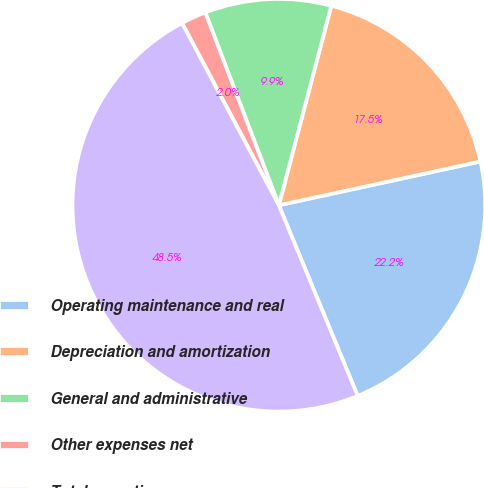Convert chart. <chart><loc_0><loc_0><loc_500><loc_500><pie_chart><fcel>Operating maintenance and real<fcel>Depreciation and amortization<fcel>General and administrative<fcel>Other expenses net<fcel>Total operating expenses<nl><fcel>22.16%<fcel>17.51%<fcel>9.89%<fcel>1.97%<fcel>48.47%<nl></chart> 